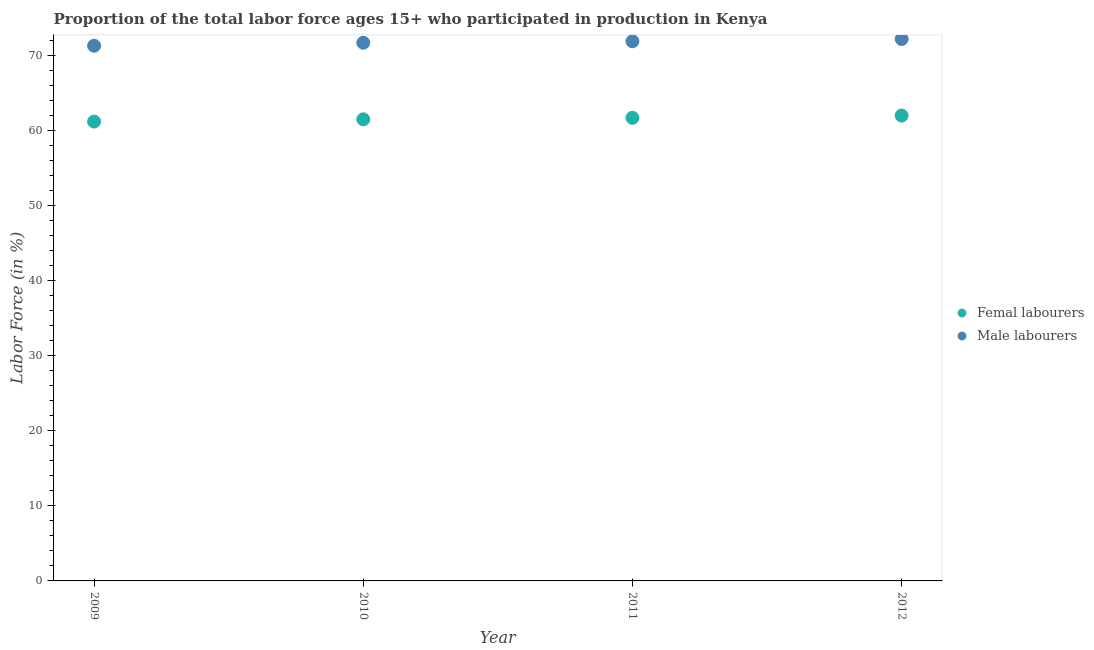What is the percentage of female labor force in 2010?
Your response must be concise. 61.5. Across all years, what is the minimum percentage of male labour force?
Offer a terse response. 71.3. In which year was the percentage of female labor force minimum?
Your answer should be very brief. 2009. What is the total percentage of male labour force in the graph?
Your response must be concise. 287.1. What is the difference between the percentage of female labor force in 2011 and that in 2012?
Offer a terse response. -0.3. What is the difference between the percentage of male labour force in 2011 and the percentage of female labor force in 2009?
Provide a short and direct response. 10.7. What is the average percentage of female labor force per year?
Keep it short and to the point. 61.6. In the year 2009, what is the difference between the percentage of male labour force and percentage of female labor force?
Offer a very short reply. 10.1. In how many years, is the percentage of female labor force greater than 44 %?
Offer a very short reply. 4. What is the ratio of the percentage of male labour force in 2011 to that in 2012?
Your answer should be very brief. 1. Is the percentage of female labor force in 2009 less than that in 2012?
Make the answer very short. Yes. What is the difference between the highest and the second highest percentage of female labor force?
Provide a short and direct response. 0.3. What is the difference between the highest and the lowest percentage of female labor force?
Give a very brief answer. 0.8. How many years are there in the graph?
Your answer should be compact. 4. Are the values on the major ticks of Y-axis written in scientific E-notation?
Your response must be concise. No. Does the graph contain any zero values?
Your response must be concise. No. Where does the legend appear in the graph?
Your answer should be compact. Center right. What is the title of the graph?
Ensure brevity in your answer.  Proportion of the total labor force ages 15+ who participated in production in Kenya. What is the label or title of the X-axis?
Your response must be concise. Year. What is the label or title of the Y-axis?
Give a very brief answer. Labor Force (in %). What is the Labor Force (in %) of Femal labourers in 2009?
Your answer should be very brief. 61.2. What is the Labor Force (in %) of Male labourers in 2009?
Keep it short and to the point. 71.3. What is the Labor Force (in %) of Femal labourers in 2010?
Offer a very short reply. 61.5. What is the Labor Force (in %) of Male labourers in 2010?
Provide a short and direct response. 71.7. What is the Labor Force (in %) in Femal labourers in 2011?
Provide a succinct answer. 61.7. What is the Labor Force (in %) in Male labourers in 2011?
Provide a short and direct response. 71.9. What is the Labor Force (in %) of Femal labourers in 2012?
Keep it short and to the point. 62. What is the Labor Force (in %) of Male labourers in 2012?
Provide a succinct answer. 72.2. Across all years, what is the maximum Labor Force (in %) in Male labourers?
Your answer should be very brief. 72.2. Across all years, what is the minimum Labor Force (in %) of Femal labourers?
Keep it short and to the point. 61.2. Across all years, what is the minimum Labor Force (in %) of Male labourers?
Provide a succinct answer. 71.3. What is the total Labor Force (in %) of Femal labourers in the graph?
Make the answer very short. 246.4. What is the total Labor Force (in %) in Male labourers in the graph?
Make the answer very short. 287.1. What is the difference between the Labor Force (in %) in Femal labourers in 2009 and that in 2010?
Offer a very short reply. -0.3. What is the difference between the Labor Force (in %) in Femal labourers in 2009 and that in 2012?
Ensure brevity in your answer.  -0.8. What is the difference between the Labor Force (in %) in Femal labourers in 2010 and that in 2011?
Keep it short and to the point. -0.2. What is the difference between the Labor Force (in %) in Male labourers in 2010 and that in 2012?
Ensure brevity in your answer.  -0.5. What is the difference between the Labor Force (in %) in Femal labourers in 2011 and that in 2012?
Keep it short and to the point. -0.3. What is the difference between the Labor Force (in %) of Male labourers in 2011 and that in 2012?
Your answer should be very brief. -0.3. What is the difference between the Labor Force (in %) in Femal labourers in 2009 and the Labor Force (in %) in Male labourers in 2011?
Your response must be concise. -10.7. What is the difference between the Labor Force (in %) of Femal labourers in 2009 and the Labor Force (in %) of Male labourers in 2012?
Provide a succinct answer. -11. What is the difference between the Labor Force (in %) of Femal labourers in 2010 and the Labor Force (in %) of Male labourers in 2011?
Your answer should be very brief. -10.4. What is the difference between the Labor Force (in %) of Femal labourers in 2010 and the Labor Force (in %) of Male labourers in 2012?
Your answer should be very brief. -10.7. What is the average Labor Force (in %) of Femal labourers per year?
Your answer should be very brief. 61.6. What is the average Labor Force (in %) in Male labourers per year?
Offer a very short reply. 71.78. In the year 2009, what is the difference between the Labor Force (in %) in Femal labourers and Labor Force (in %) in Male labourers?
Offer a terse response. -10.1. In the year 2010, what is the difference between the Labor Force (in %) of Femal labourers and Labor Force (in %) of Male labourers?
Provide a short and direct response. -10.2. In the year 2011, what is the difference between the Labor Force (in %) in Femal labourers and Labor Force (in %) in Male labourers?
Offer a very short reply. -10.2. What is the ratio of the Labor Force (in %) in Femal labourers in 2009 to that in 2010?
Provide a short and direct response. 1. What is the ratio of the Labor Force (in %) of Male labourers in 2009 to that in 2010?
Provide a short and direct response. 0.99. What is the ratio of the Labor Force (in %) of Femal labourers in 2009 to that in 2011?
Provide a short and direct response. 0.99. What is the ratio of the Labor Force (in %) in Femal labourers in 2009 to that in 2012?
Your answer should be very brief. 0.99. What is the ratio of the Labor Force (in %) in Male labourers in 2009 to that in 2012?
Provide a succinct answer. 0.99. What is the ratio of the Labor Force (in %) of Femal labourers in 2010 to that in 2011?
Offer a very short reply. 1. What is the difference between the highest and the second highest Labor Force (in %) in Femal labourers?
Keep it short and to the point. 0.3. What is the difference between the highest and the lowest Labor Force (in %) in Femal labourers?
Offer a terse response. 0.8. 